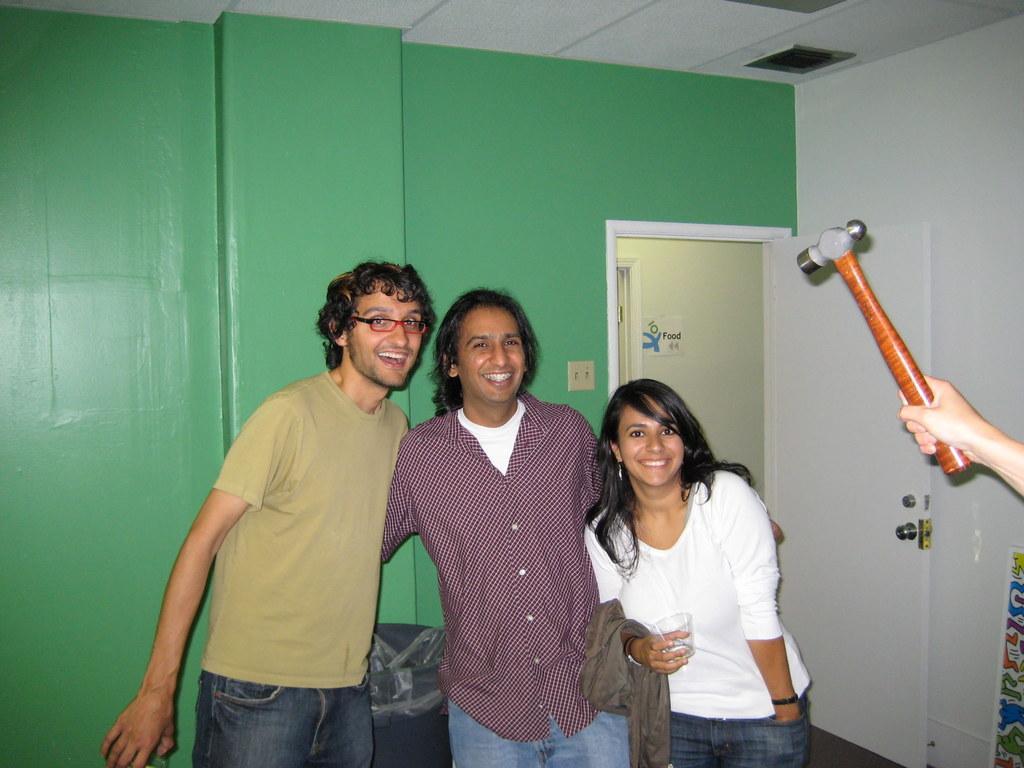How would you summarize this image in a sentence or two? In the image there are three people standing and posing for the photo, on the right side there is some person holding a hammer with the hand, in the background there is a wall and beside the wall there is a door. 